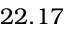Convert formula to latex. <formula><loc_0><loc_0><loc_500><loc_500>2 2 . 1 7</formula> 